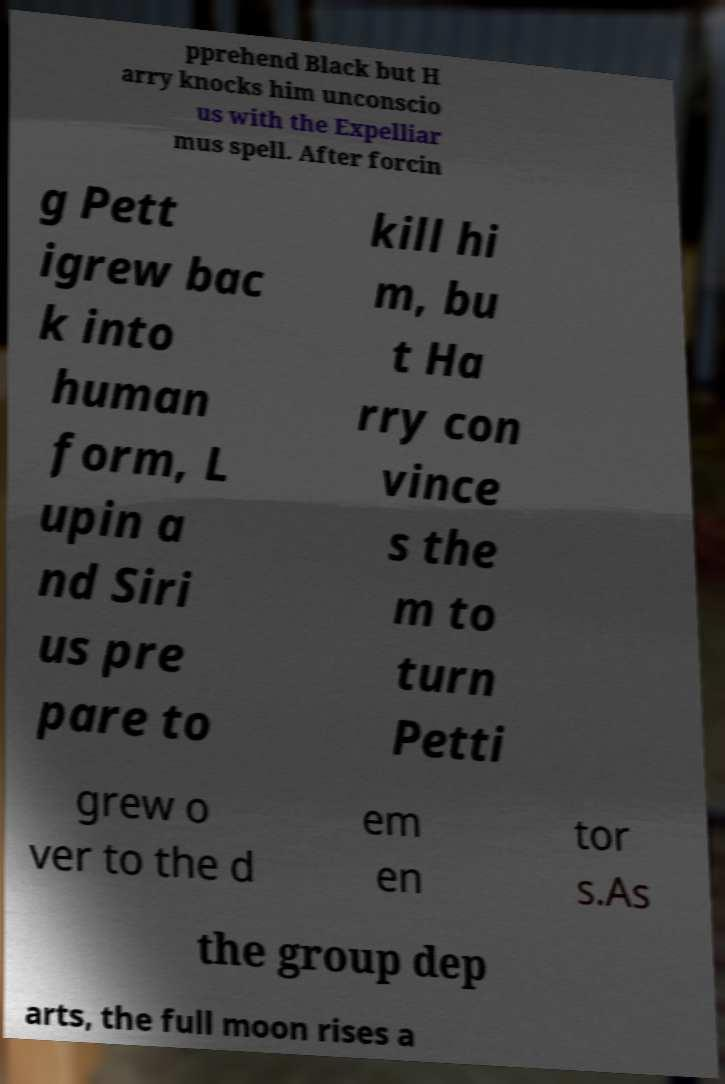Can you accurately transcribe the text from the provided image for me? pprehend Black but H arry knocks him unconscio us with the Expelliar mus spell. After forcin g Pett igrew bac k into human form, L upin a nd Siri us pre pare to kill hi m, bu t Ha rry con vince s the m to turn Petti grew o ver to the d em en tor s.As the group dep arts, the full moon rises a 